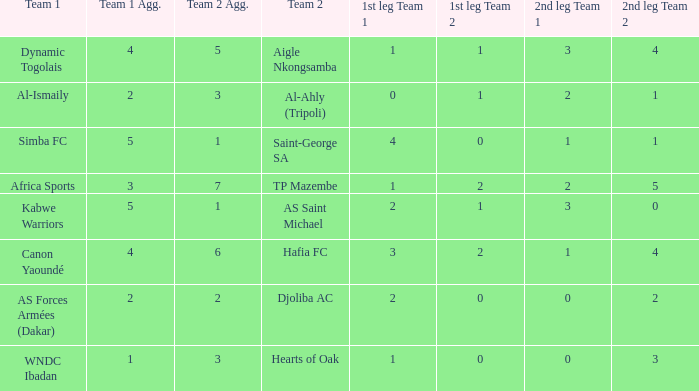What team played against Al-Ismaily (team 1)? Al-Ahly (Tripoli). 